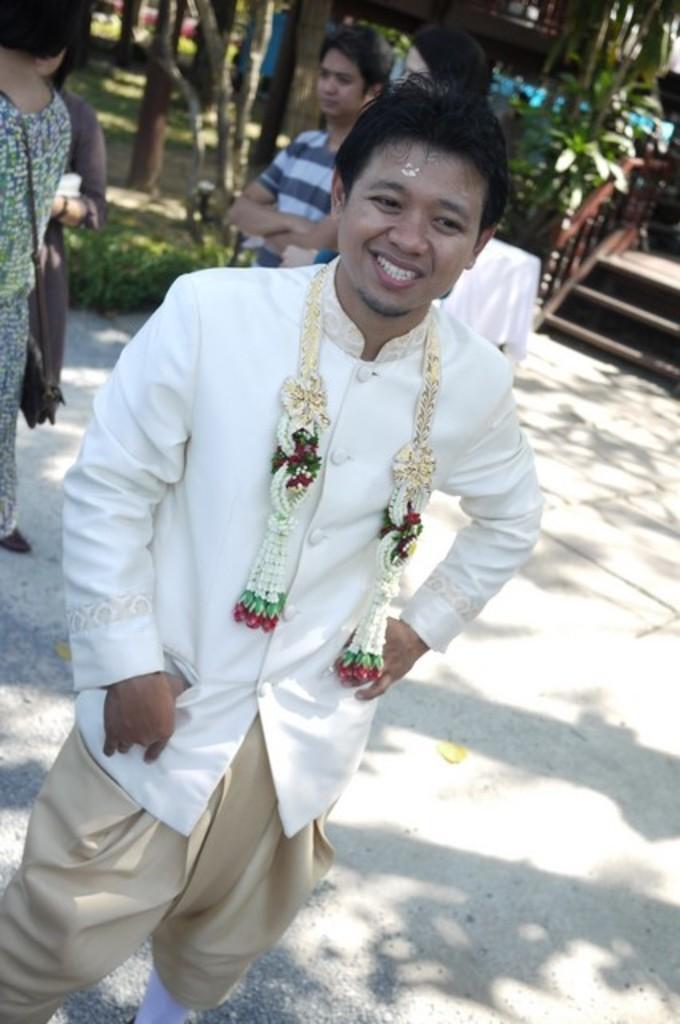Please provide a concise description of this image. In this image, we can see persons wearing clothes. There is a staircase in the top right of the image. There are stems at the top of the image. 